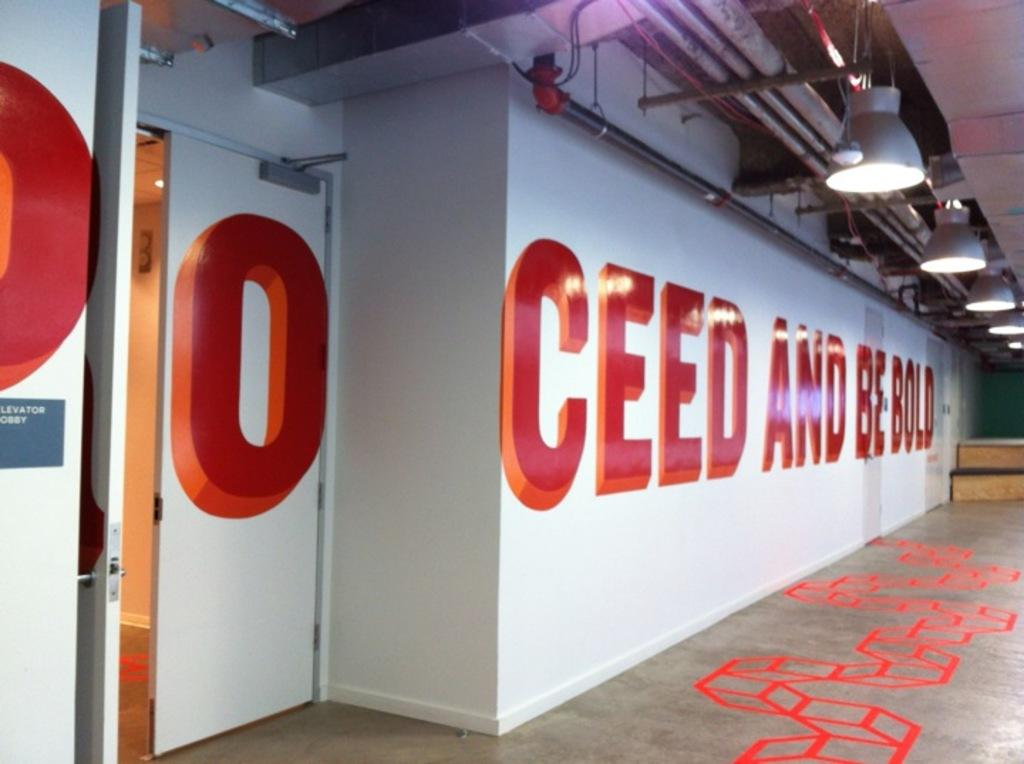What is the color of the paintings on the floor in the image? The paintings on the floor in the image are red. What other architectural element can be seen in the image? There is a wall in the image. What is located on the roof in the image? There are lights on the roof in the image. Can you tell me how many cacti are present in the image? There are no cacti present in the image. What type of dinner is being served in the image? There is no dinner present in the image. 